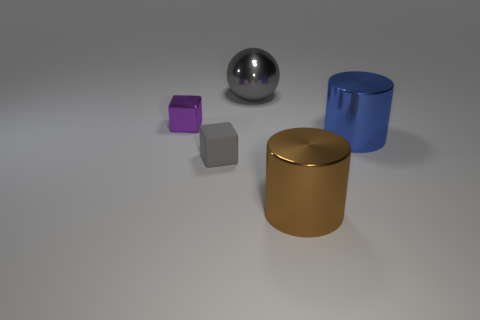Add 3 metallic cylinders. How many objects exist? 8 Subtract all blocks. How many objects are left? 3 Add 4 large blue metallic cylinders. How many large blue metallic cylinders exist? 5 Subtract 0 red blocks. How many objects are left? 5 Subtract all tiny gray objects. Subtract all small yellow matte spheres. How many objects are left? 4 Add 1 small purple metallic objects. How many small purple metallic objects are left? 2 